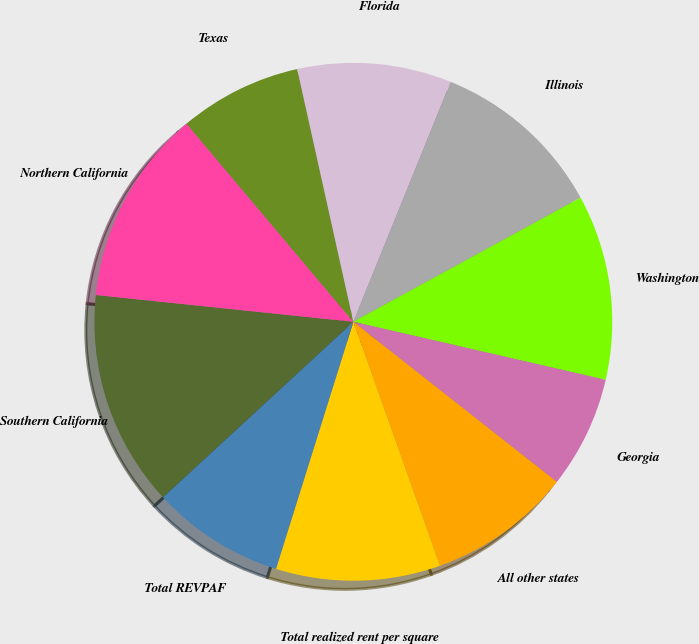Convert chart. <chart><loc_0><loc_0><loc_500><loc_500><pie_chart><fcel>Southern California<fcel>Northern California<fcel>Texas<fcel>Florida<fcel>Illinois<fcel>Washington<fcel>Georgia<fcel>All other states<fcel>Total realized rent per square<fcel>Total REVPAF<nl><fcel>13.51%<fcel>12.21%<fcel>7.66%<fcel>9.61%<fcel>10.91%<fcel>11.56%<fcel>7.01%<fcel>8.96%<fcel>10.26%<fcel>8.31%<nl></chart> 